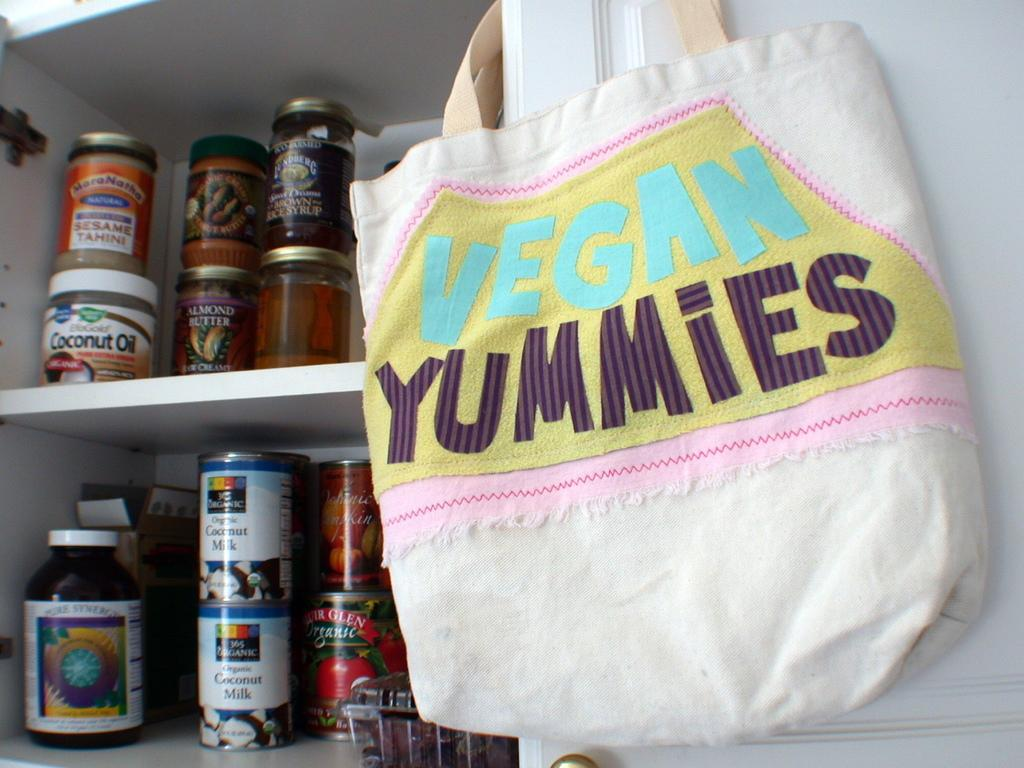What objects are on shelves in the image? There are bottles on shelves in the image. Where is the bag located in the image? The bag is on the wall in the image. What type of behavior can be observed in the bottles in the image? There is no behavior to observe in the bottles, as they are inanimate objects. Is there any toothpaste visible in the image? There is no mention of toothpaste in the provided facts, so it cannot be determined if it is present in the image. 